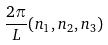<formula> <loc_0><loc_0><loc_500><loc_500>\frac { 2 \pi } { L } ( n _ { 1 } , n _ { 2 } , n _ { 3 } )</formula> 